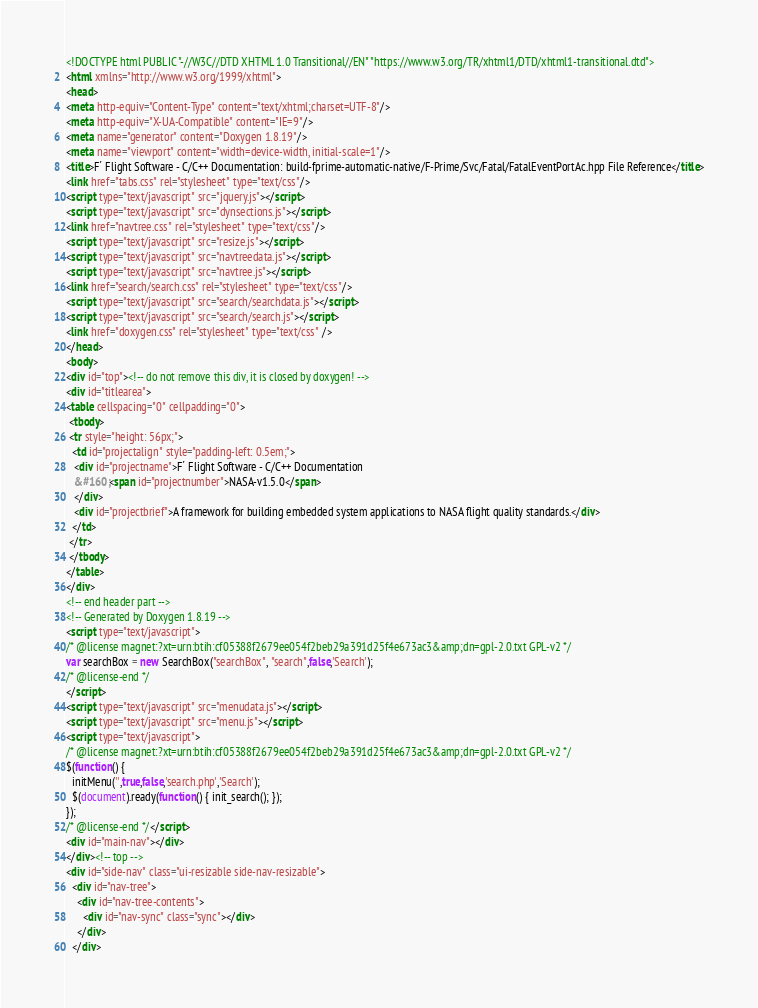Convert code to text. <code><loc_0><loc_0><loc_500><loc_500><_HTML_><!DOCTYPE html PUBLIC "-//W3C//DTD XHTML 1.0 Transitional//EN" "https://www.w3.org/TR/xhtml1/DTD/xhtml1-transitional.dtd">
<html xmlns="http://www.w3.org/1999/xhtml">
<head>
<meta http-equiv="Content-Type" content="text/xhtml;charset=UTF-8"/>
<meta http-equiv="X-UA-Compatible" content="IE=9"/>
<meta name="generator" content="Doxygen 1.8.19"/>
<meta name="viewport" content="width=device-width, initial-scale=1"/>
<title>F´ Flight Software - C/C++ Documentation: build-fprime-automatic-native/F-Prime/Svc/Fatal/FatalEventPortAc.hpp File Reference</title>
<link href="tabs.css" rel="stylesheet" type="text/css"/>
<script type="text/javascript" src="jquery.js"></script>
<script type="text/javascript" src="dynsections.js"></script>
<link href="navtree.css" rel="stylesheet" type="text/css"/>
<script type="text/javascript" src="resize.js"></script>
<script type="text/javascript" src="navtreedata.js"></script>
<script type="text/javascript" src="navtree.js"></script>
<link href="search/search.css" rel="stylesheet" type="text/css"/>
<script type="text/javascript" src="search/searchdata.js"></script>
<script type="text/javascript" src="search/search.js"></script>
<link href="doxygen.css" rel="stylesheet" type="text/css" />
</head>
<body>
<div id="top"><!-- do not remove this div, it is closed by doxygen! -->
<div id="titlearea">
<table cellspacing="0" cellpadding="0">
 <tbody>
 <tr style="height: 56px;">
  <td id="projectalign" style="padding-left: 0.5em;">
   <div id="projectname">F´ Flight Software - C/C++ Documentation
   &#160;<span id="projectnumber">NASA-v1.5.0</span>
   </div>
   <div id="projectbrief">A framework for building embedded system applications to NASA flight quality standards.</div>
  </td>
 </tr>
 </tbody>
</table>
</div>
<!-- end header part -->
<!-- Generated by Doxygen 1.8.19 -->
<script type="text/javascript">
/* @license magnet:?xt=urn:btih:cf05388f2679ee054f2beb29a391d25f4e673ac3&amp;dn=gpl-2.0.txt GPL-v2 */
var searchBox = new SearchBox("searchBox", "search",false,'Search');
/* @license-end */
</script>
<script type="text/javascript" src="menudata.js"></script>
<script type="text/javascript" src="menu.js"></script>
<script type="text/javascript">
/* @license magnet:?xt=urn:btih:cf05388f2679ee054f2beb29a391d25f4e673ac3&amp;dn=gpl-2.0.txt GPL-v2 */
$(function() {
  initMenu('',true,false,'search.php','Search');
  $(document).ready(function() { init_search(); });
});
/* @license-end */</script>
<div id="main-nav"></div>
</div><!-- top -->
<div id="side-nav" class="ui-resizable side-nav-resizable">
  <div id="nav-tree">
    <div id="nav-tree-contents">
      <div id="nav-sync" class="sync"></div>
    </div>
  </div></code> 